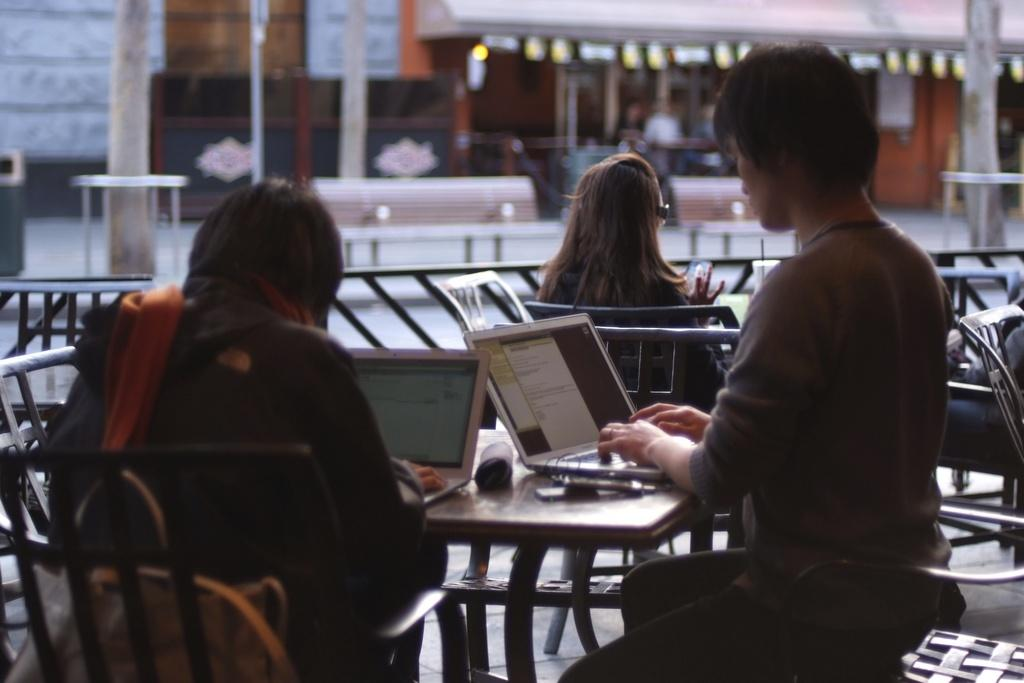How many people are sitting in the image? There are 3 people sitting on chairs in the image. What electronic devices can be seen on the table? There are 2 laptops on a table in the image. What can be seen in the background of the image? There are buildings and 2 benches in the background of the image. Can you see a locket around the neck of any person in the image? There is no locket visible around the neck of any person in the image. How do the benches move in the image? The benches do not move in the image; they are stationary in the background. 